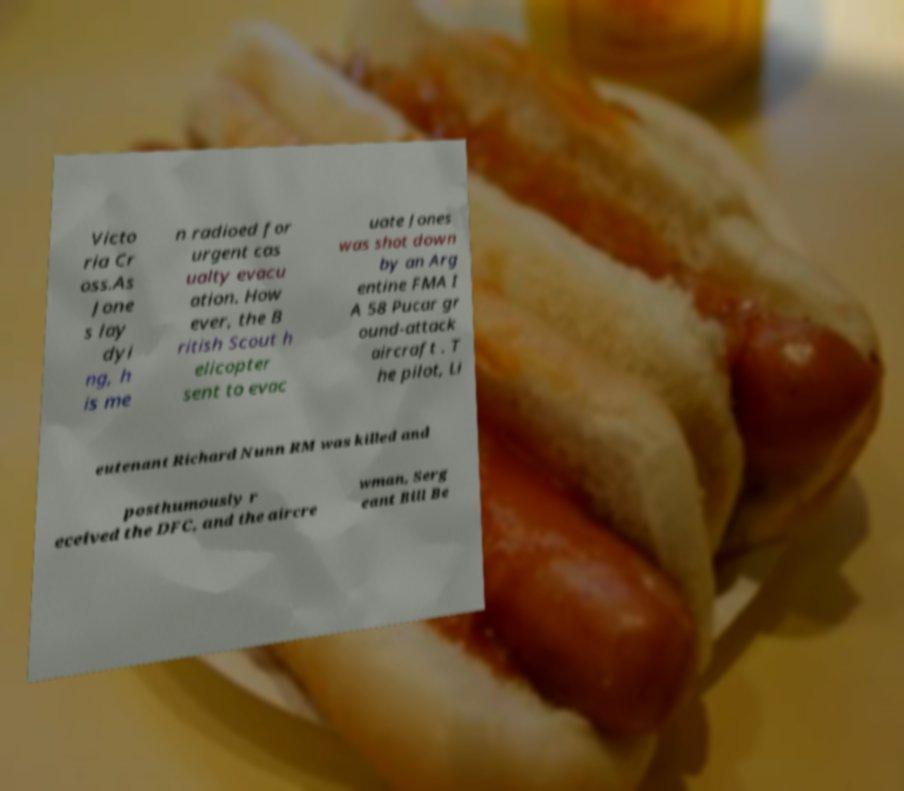There's text embedded in this image that I need extracted. Can you transcribe it verbatim? Victo ria Cr oss.As Jone s lay dyi ng, h is me n radioed for urgent cas ualty evacu ation. How ever, the B ritish Scout h elicopter sent to evac uate Jones was shot down by an Arg entine FMA I A 58 Pucar gr ound-attack aircraft . T he pilot, Li eutenant Richard Nunn RM was killed and posthumously r eceived the DFC, and the aircre wman, Serg eant Bill Be 